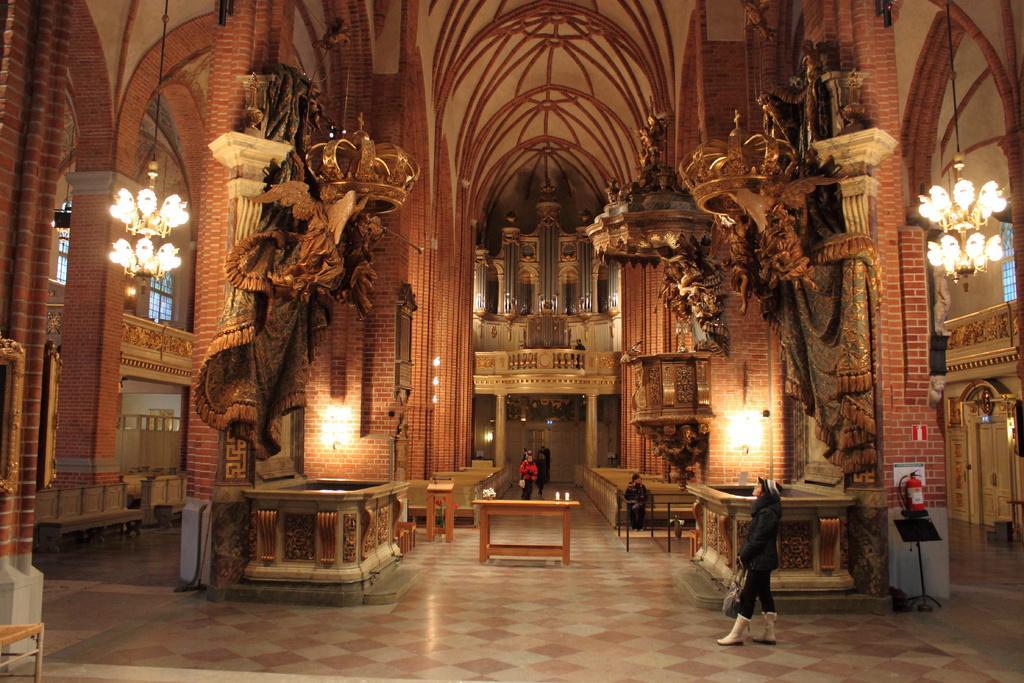Can you describe this image briefly? In this picture there are people and we can see objects on the table. We can see benches, chandeliers, crowns, statues, boards, fire extinguisher, objects and floor. In the background of the image we can see windows, lights and railings. 